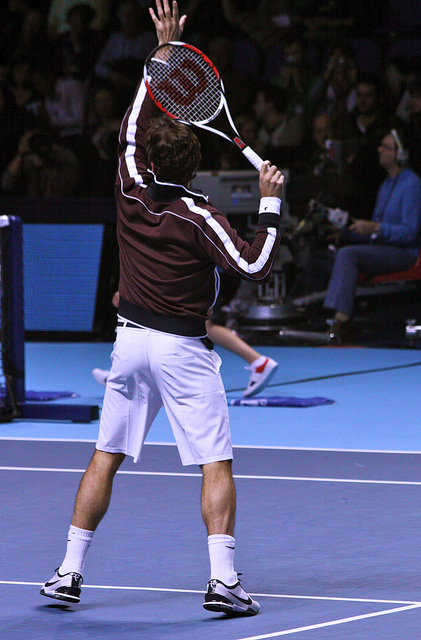<image>Is this a man? It is unknown if this is a man. However, it can be as the majority of answers indicate 'yes'. Is this a man? I don't know if this is a man or not. It is difficult to determine based on the given information. 